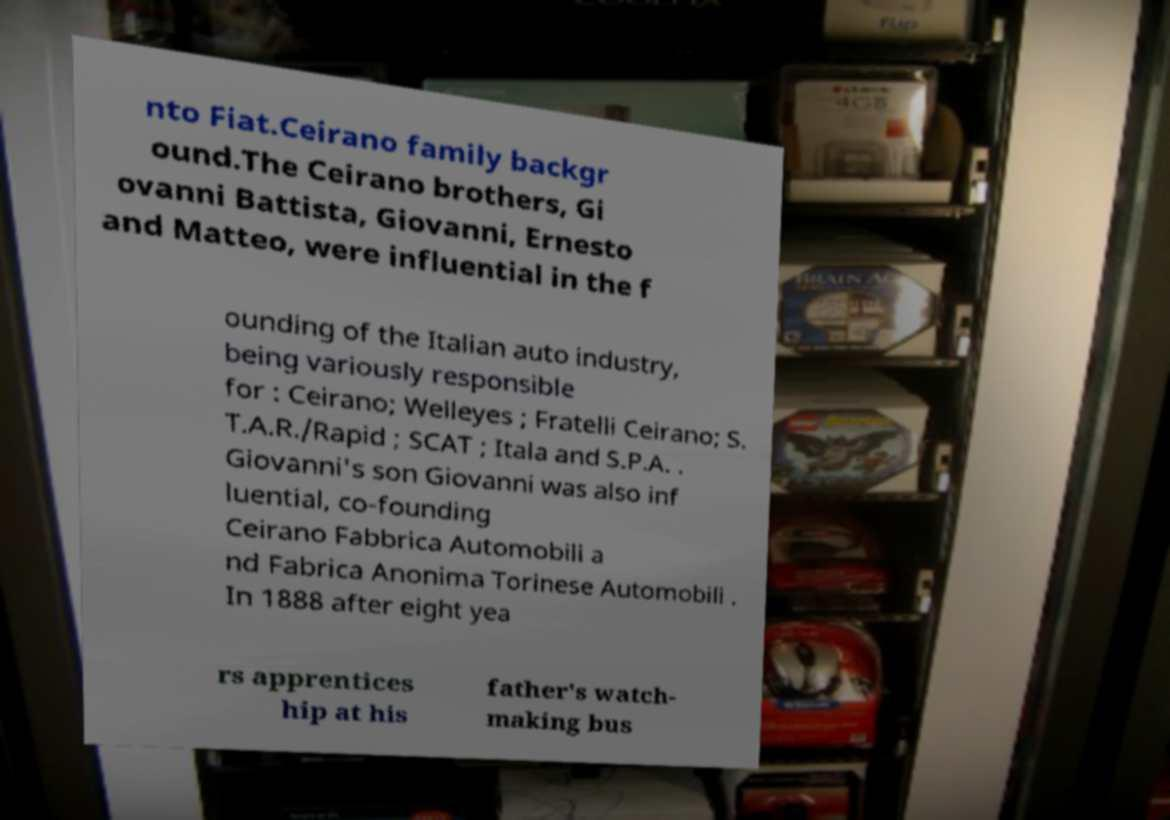Can you accurately transcribe the text from the provided image for me? nto Fiat.Ceirano family backgr ound.The Ceirano brothers, Gi ovanni Battista, Giovanni, Ernesto and Matteo, were influential in the f ounding of the Italian auto industry, being variously responsible for : Ceirano; Welleyes ; Fratelli Ceirano; S. T.A.R./Rapid ; SCAT ; Itala and S.P.A. . Giovanni's son Giovanni was also inf luential, co-founding Ceirano Fabbrica Automobili a nd Fabrica Anonima Torinese Automobili . In 1888 after eight yea rs apprentices hip at his father's watch- making bus 